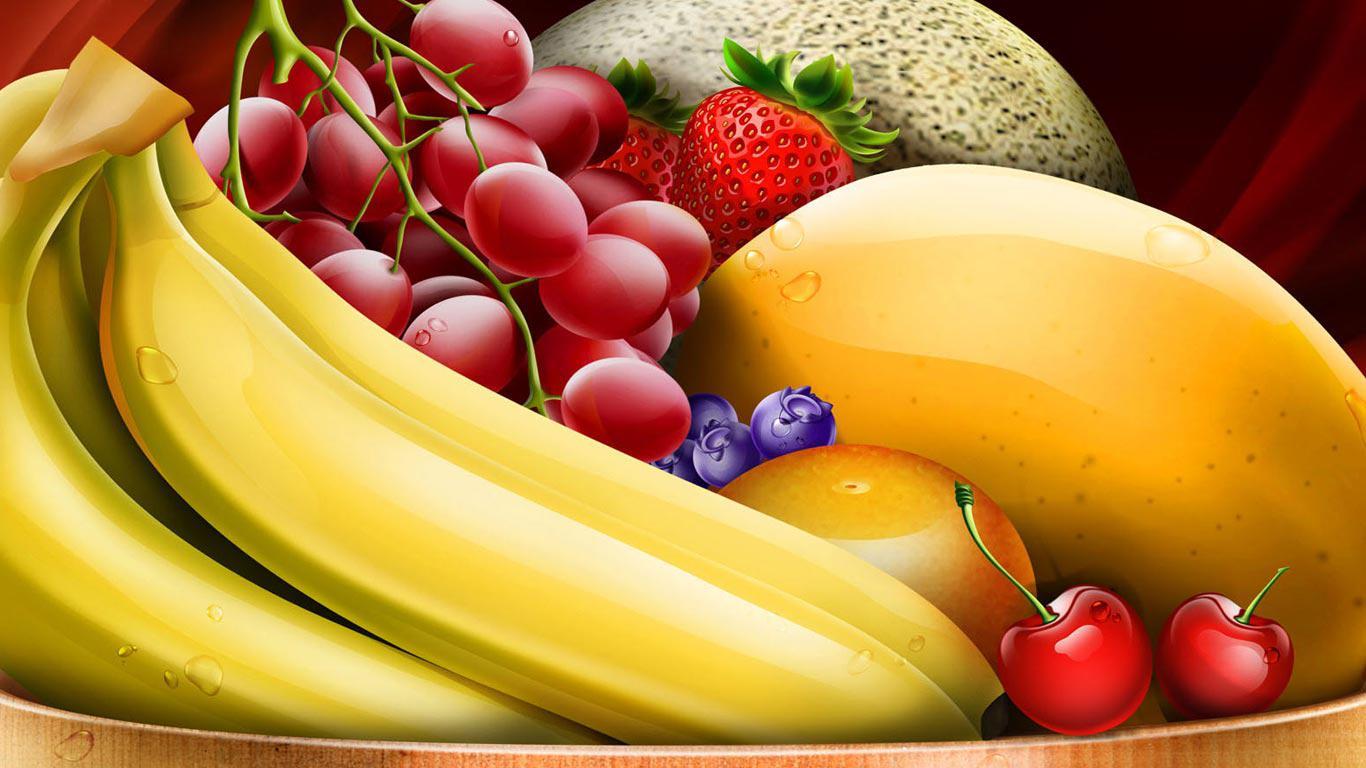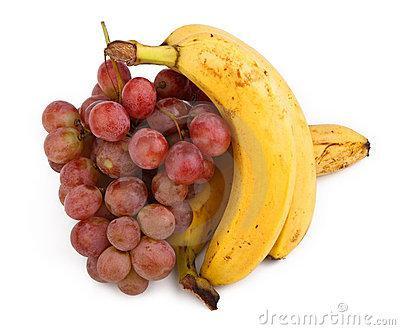The first image is the image on the left, the second image is the image on the right. Given the left and right images, does the statement "There are red grapes and green grapes beside each-other in one of the images." hold true? Answer yes or no. No. The first image is the image on the left, the second image is the image on the right. Evaluate the accuracy of this statement regarding the images: "One of the images has at least one apple.". Is it true? Answer yes or no. No. 